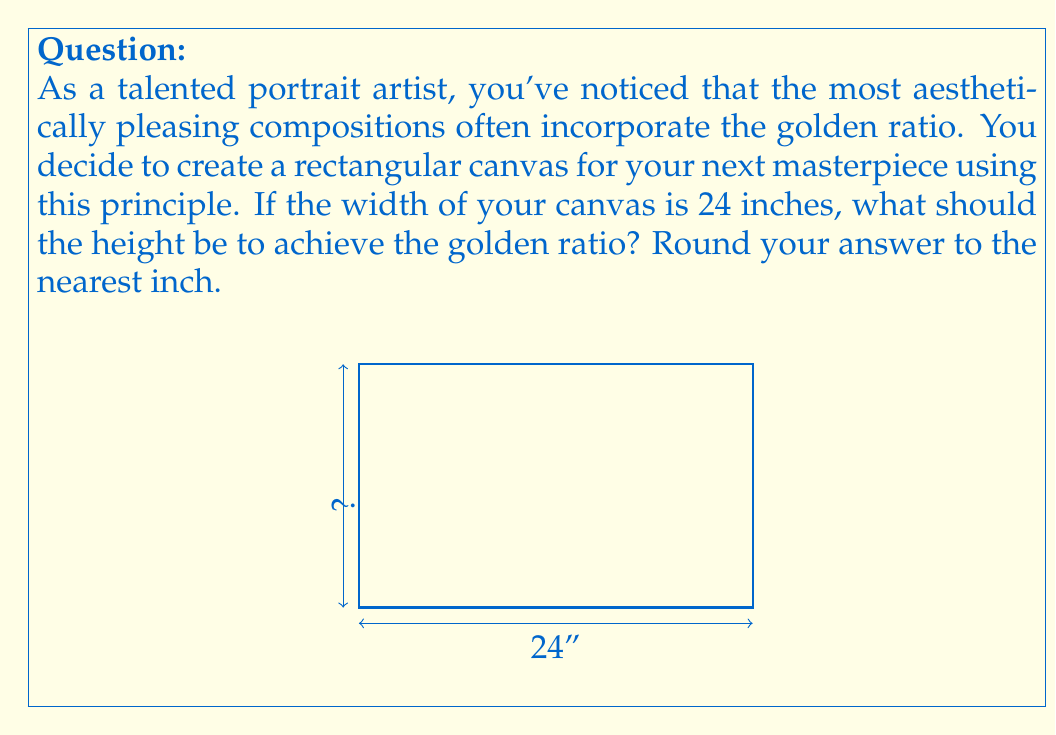Can you solve this math problem? Let's approach this step-by-step:

1) The golden ratio, often denoted by the Greek letter φ (phi), is defined as:

   $$\phi = \frac{1 + \sqrt{5}}{2} \approx 1.618033989$$

2) In a rectangle with the golden ratio, the ratio of the longer side to the shorter side is equal to φ. If we denote the width as w and the height as h, we have:

   $$\frac{h}{w} = \phi$$

3) We know the width is 24 inches, so we can substitute this:

   $$\frac{h}{24} = \frac{1 + \sqrt{5}}{2}$$

4) To solve for h, multiply both sides by 24:

   $$h = 24 \cdot \frac{1 + \sqrt{5}}{2}$$

5) Let's calculate this:

   $$h = 24 \cdot \frac{1 + \sqrt{5}}{2} = 12(1 + \sqrt{5}) = 12 + 12\sqrt{5}$$

6) Now, let's evaluate $12\sqrt{5}$:
   
   $$12\sqrt{5} \approx 26.8328$$

7) Adding this to 12:

   $$h \approx 12 + 26.8328 = 38.8328$$

8) Rounding to the nearest inch:

   $$h \approx 39\text{ inches}$$

Therefore, for a 24-inch wide canvas, the height should be approximately 39 inches to achieve the golden ratio.
Answer: 39 inches 